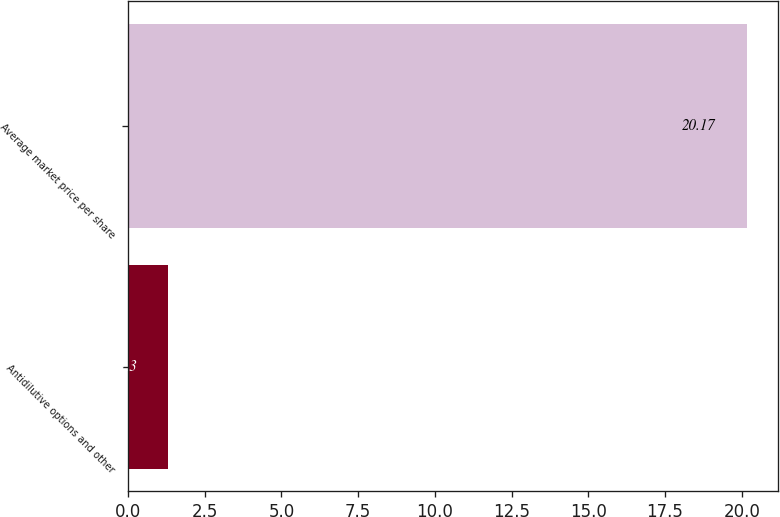Convert chart to OTSL. <chart><loc_0><loc_0><loc_500><loc_500><bar_chart><fcel>Antidilutive options and other<fcel>Average market price per share<nl><fcel>1.3<fcel>20.17<nl></chart> 